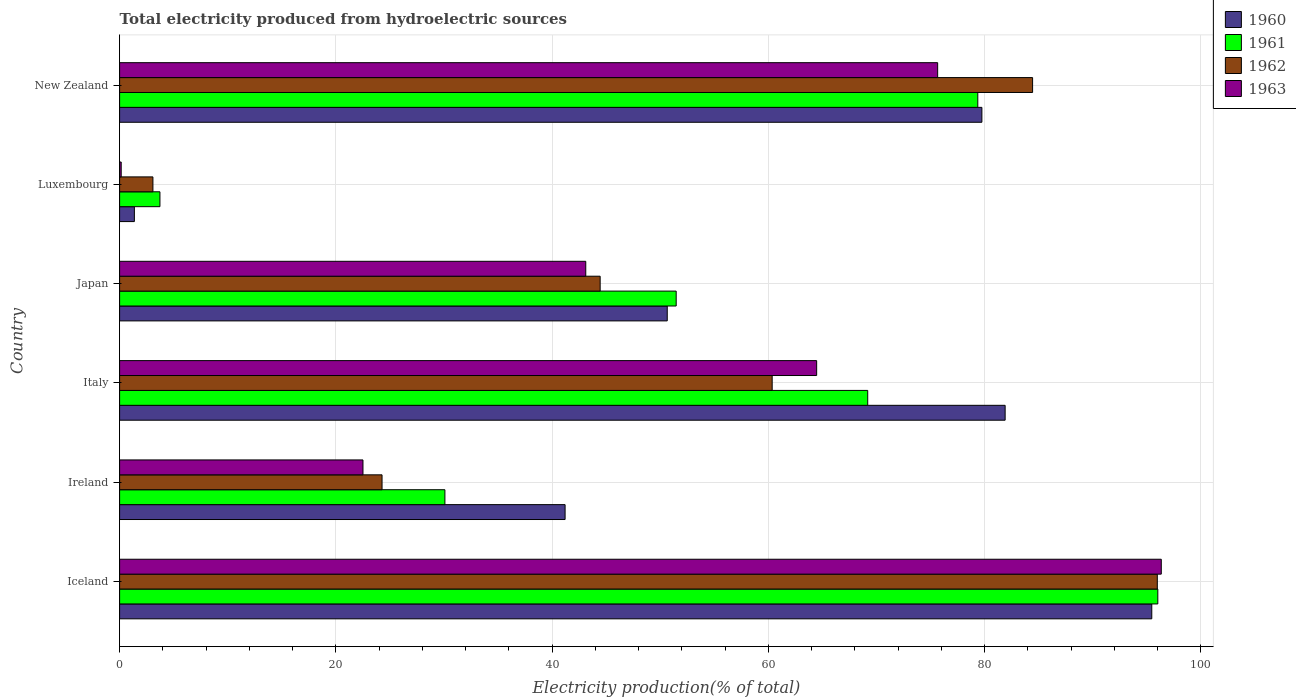How many groups of bars are there?
Keep it short and to the point. 6. Are the number of bars per tick equal to the number of legend labels?
Provide a succinct answer. Yes. How many bars are there on the 4th tick from the bottom?
Give a very brief answer. 4. What is the total electricity produced in 1963 in New Zealand?
Make the answer very short. 75.66. Across all countries, what is the maximum total electricity produced in 1962?
Provide a succinct answer. 95.97. Across all countries, what is the minimum total electricity produced in 1962?
Offer a very short reply. 3.08. In which country was the total electricity produced in 1962 minimum?
Provide a short and direct response. Luxembourg. What is the total total electricity produced in 1962 in the graph?
Offer a very short reply. 312.57. What is the difference between the total electricity produced in 1960 in Italy and that in New Zealand?
Make the answer very short. 2.15. What is the difference between the total electricity produced in 1962 in Iceland and the total electricity produced in 1961 in New Zealand?
Offer a very short reply. 16.6. What is the average total electricity produced in 1961 per country?
Your answer should be compact. 54.98. What is the difference between the total electricity produced in 1962 and total electricity produced in 1961 in Japan?
Provide a short and direct response. -7.03. In how many countries, is the total electricity produced in 1961 greater than 92 %?
Provide a short and direct response. 1. What is the ratio of the total electricity produced in 1963 in Ireland to that in Italy?
Your answer should be compact. 0.35. What is the difference between the highest and the second highest total electricity produced in 1963?
Provide a succinct answer. 20.68. What is the difference between the highest and the lowest total electricity produced in 1960?
Provide a short and direct response. 94.1. In how many countries, is the total electricity produced in 1962 greater than the average total electricity produced in 1962 taken over all countries?
Ensure brevity in your answer.  3. Is the sum of the total electricity produced in 1962 in Luxembourg and New Zealand greater than the maximum total electricity produced in 1963 across all countries?
Your answer should be compact. No. Is it the case that in every country, the sum of the total electricity produced in 1963 and total electricity produced in 1961 is greater than the sum of total electricity produced in 1962 and total electricity produced in 1960?
Ensure brevity in your answer.  No. What does the 4th bar from the bottom in Japan represents?
Provide a short and direct response. 1963. What is the difference between two consecutive major ticks on the X-axis?
Make the answer very short. 20. Does the graph contain grids?
Provide a succinct answer. Yes. How many legend labels are there?
Provide a succinct answer. 4. What is the title of the graph?
Make the answer very short. Total electricity produced from hydroelectric sources. What is the Electricity production(% of total) of 1960 in Iceland?
Offer a very short reply. 95.46. What is the Electricity production(% of total) in 1961 in Iceland?
Your response must be concise. 96.02. What is the Electricity production(% of total) in 1962 in Iceland?
Ensure brevity in your answer.  95.97. What is the Electricity production(% of total) in 1963 in Iceland?
Your response must be concise. 96.34. What is the Electricity production(% of total) in 1960 in Ireland?
Offer a very short reply. 41.2. What is the Electricity production(% of total) of 1961 in Ireland?
Keep it short and to the point. 30.09. What is the Electricity production(% of total) of 1962 in Ireland?
Your answer should be compact. 24.27. What is the Electricity production(% of total) of 1963 in Ireland?
Your answer should be very brief. 22.51. What is the Electricity production(% of total) in 1960 in Italy?
Your answer should be very brief. 81.9. What is the Electricity production(% of total) of 1961 in Italy?
Keep it short and to the point. 69.19. What is the Electricity production(% of total) of 1962 in Italy?
Provide a short and direct response. 60.35. What is the Electricity production(% of total) of 1963 in Italy?
Offer a terse response. 64.47. What is the Electricity production(% of total) of 1960 in Japan?
Make the answer very short. 50.65. What is the Electricity production(% of total) of 1961 in Japan?
Your answer should be compact. 51.48. What is the Electricity production(% of total) in 1962 in Japan?
Offer a terse response. 44.44. What is the Electricity production(% of total) in 1963 in Japan?
Ensure brevity in your answer.  43.11. What is the Electricity production(% of total) in 1960 in Luxembourg?
Ensure brevity in your answer.  1.37. What is the Electricity production(% of total) in 1961 in Luxembourg?
Make the answer very short. 3.73. What is the Electricity production(% of total) in 1962 in Luxembourg?
Provide a succinct answer. 3.08. What is the Electricity production(% of total) in 1963 in Luxembourg?
Keep it short and to the point. 0.15. What is the Electricity production(% of total) of 1960 in New Zealand?
Your response must be concise. 79.75. What is the Electricity production(% of total) of 1961 in New Zealand?
Your answer should be very brief. 79.37. What is the Electricity production(% of total) in 1962 in New Zealand?
Your response must be concise. 84.44. What is the Electricity production(% of total) in 1963 in New Zealand?
Provide a succinct answer. 75.66. Across all countries, what is the maximum Electricity production(% of total) in 1960?
Offer a very short reply. 95.46. Across all countries, what is the maximum Electricity production(% of total) of 1961?
Provide a short and direct response. 96.02. Across all countries, what is the maximum Electricity production(% of total) of 1962?
Give a very brief answer. 95.97. Across all countries, what is the maximum Electricity production(% of total) in 1963?
Offer a very short reply. 96.34. Across all countries, what is the minimum Electricity production(% of total) in 1960?
Offer a terse response. 1.37. Across all countries, what is the minimum Electricity production(% of total) in 1961?
Provide a succinct answer. 3.73. Across all countries, what is the minimum Electricity production(% of total) in 1962?
Offer a terse response. 3.08. Across all countries, what is the minimum Electricity production(% of total) of 1963?
Your response must be concise. 0.15. What is the total Electricity production(% of total) in 1960 in the graph?
Keep it short and to the point. 350.33. What is the total Electricity production(% of total) of 1961 in the graph?
Give a very brief answer. 329.87. What is the total Electricity production(% of total) of 1962 in the graph?
Offer a terse response. 312.57. What is the total Electricity production(% of total) of 1963 in the graph?
Provide a short and direct response. 302.24. What is the difference between the Electricity production(% of total) of 1960 in Iceland and that in Ireland?
Your answer should be very brief. 54.26. What is the difference between the Electricity production(% of total) in 1961 in Iceland and that in Ireland?
Keep it short and to the point. 65.93. What is the difference between the Electricity production(% of total) of 1962 in Iceland and that in Ireland?
Provide a short and direct response. 71.7. What is the difference between the Electricity production(% of total) of 1963 in Iceland and that in Ireland?
Ensure brevity in your answer.  73.83. What is the difference between the Electricity production(% of total) in 1960 in Iceland and that in Italy?
Provide a short and direct response. 13.56. What is the difference between the Electricity production(% of total) of 1961 in Iceland and that in Italy?
Ensure brevity in your answer.  26.83. What is the difference between the Electricity production(% of total) of 1962 in Iceland and that in Italy?
Your answer should be very brief. 35.62. What is the difference between the Electricity production(% of total) in 1963 in Iceland and that in Italy?
Offer a very short reply. 31.87. What is the difference between the Electricity production(% of total) of 1960 in Iceland and that in Japan?
Offer a very short reply. 44.81. What is the difference between the Electricity production(% of total) in 1961 in Iceland and that in Japan?
Your answer should be compact. 44.54. What is the difference between the Electricity production(% of total) of 1962 in Iceland and that in Japan?
Make the answer very short. 51.53. What is the difference between the Electricity production(% of total) in 1963 in Iceland and that in Japan?
Give a very brief answer. 53.23. What is the difference between the Electricity production(% of total) of 1960 in Iceland and that in Luxembourg?
Give a very brief answer. 94.1. What is the difference between the Electricity production(% of total) of 1961 in Iceland and that in Luxembourg?
Your response must be concise. 92.29. What is the difference between the Electricity production(% of total) in 1962 in Iceland and that in Luxembourg?
Give a very brief answer. 92.89. What is the difference between the Electricity production(% of total) of 1963 in Iceland and that in Luxembourg?
Keep it short and to the point. 96.19. What is the difference between the Electricity production(% of total) of 1960 in Iceland and that in New Zealand?
Give a very brief answer. 15.71. What is the difference between the Electricity production(% of total) of 1961 in Iceland and that in New Zealand?
Offer a very short reply. 16.65. What is the difference between the Electricity production(% of total) in 1962 in Iceland and that in New Zealand?
Offer a terse response. 11.54. What is the difference between the Electricity production(% of total) in 1963 in Iceland and that in New Zealand?
Your answer should be very brief. 20.68. What is the difference between the Electricity production(% of total) in 1960 in Ireland and that in Italy?
Offer a very short reply. -40.7. What is the difference between the Electricity production(% of total) in 1961 in Ireland and that in Italy?
Your answer should be very brief. -39.1. What is the difference between the Electricity production(% of total) in 1962 in Ireland and that in Italy?
Your answer should be very brief. -36.08. What is the difference between the Electricity production(% of total) of 1963 in Ireland and that in Italy?
Your response must be concise. -41.96. What is the difference between the Electricity production(% of total) in 1960 in Ireland and that in Japan?
Keep it short and to the point. -9.45. What is the difference between the Electricity production(% of total) of 1961 in Ireland and that in Japan?
Offer a very short reply. -21.39. What is the difference between the Electricity production(% of total) of 1962 in Ireland and that in Japan?
Keep it short and to the point. -20.17. What is the difference between the Electricity production(% of total) of 1963 in Ireland and that in Japan?
Your response must be concise. -20.61. What is the difference between the Electricity production(% of total) in 1960 in Ireland and that in Luxembourg?
Your answer should be compact. 39.84. What is the difference between the Electricity production(% of total) in 1961 in Ireland and that in Luxembourg?
Your answer should be very brief. 26.36. What is the difference between the Electricity production(% of total) of 1962 in Ireland and that in Luxembourg?
Provide a succinct answer. 21.19. What is the difference between the Electricity production(% of total) in 1963 in Ireland and that in Luxembourg?
Your answer should be compact. 22.36. What is the difference between the Electricity production(% of total) in 1960 in Ireland and that in New Zealand?
Your response must be concise. -38.55. What is the difference between the Electricity production(% of total) of 1961 in Ireland and that in New Zealand?
Your answer should be compact. -49.29. What is the difference between the Electricity production(% of total) in 1962 in Ireland and that in New Zealand?
Your answer should be compact. -60.17. What is the difference between the Electricity production(% of total) of 1963 in Ireland and that in New Zealand?
Your response must be concise. -53.15. What is the difference between the Electricity production(% of total) of 1960 in Italy and that in Japan?
Offer a very short reply. 31.25. What is the difference between the Electricity production(% of total) of 1961 in Italy and that in Japan?
Provide a short and direct response. 17.71. What is the difference between the Electricity production(% of total) in 1962 in Italy and that in Japan?
Ensure brevity in your answer.  15.91. What is the difference between the Electricity production(% of total) of 1963 in Italy and that in Japan?
Your answer should be very brief. 21.35. What is the difference between the Electricity production(% of total) in 1960 in Italy and that in Luxembourg?
Your answer should be compact. 80.53. What is the difference between the Electricity production(% of total) in 1961 in Italy and that in Luxembourg?
Provide a succinct answer. 65.46. What is the difference between the Electricity production(% of total) in 1962 in Italy and that in Luxembourg?
Your response must be concise. 57.27. What is the difference between the Electricity production(% of total) in 1963 in Italy and that in Luxembourg?
Offer a terse response. 64.32. What is the difference between the Electricity production(% of total) of 1960 in Italy and that in New Zealand?
Give a very brief answer. 2.15. What is the difference between the Electricity production(% of total) in 1961 in Italy and that in New Zealand?
Offer a very short reply. -10.18. What is the difference between the Electricity production(% of total) in 1962 in Italy and that in New Zealand?
Your answer should be very brief. -24.08. What is the difference between the Electricity production(% of total) of 1963 in Italy and that in New Zealand?
Your answer should be compact. -11.19. What is the difference between the Electricity production(% of total) of 1960 in Japan and that in Luxembourg?
Your response must be concise. 49.28. What is the difference between the Electricity production(% of total) in 1961 in Japan and that in Luxembourg?
Provide a succinct answer. 47.75. What is the difference between the Electricity production(% of total) in 1962 in Japan and that in Luxembourg?
Your response must be concise. 41.36. What is the difference between the Electricity production(% of total) in 1963 in Japan and that in Luxembourg?
Your answer should be compact. 42.97. What is the difference between the Electricity production(% of total) in 1960 in Japan and that in New Zealand?
Make the answer very short. -29.1. What is the difference between the Electricity production(% of total) in 1961 in Japan and that in New Zealand?
Make the answer very short. -27.9. What is the difference between the Electricity production(% of total) of 1962 in Japan and that in New Zealand?
Offer a very short reply. -39.99. What is the difference between the Electricity production(% of total) of 1963 in Japan and that in New Zealand?
Your answer should be compact. -32.54. What is the difference between the Electricity production(% of total) of 1960 in Luxembourg and that in New Zealand?
Make the answer very short. -78.38. What is the difference between the Electricity production(% of total) in 1961 in Luxembourg and that in New Zealand?
Your answer should be compact. -75.64. What is the difference between the Electricity production(% of total) in 1962 in Luxembourg and that in New Zealand?
Your answer should be very brief. -81.36. What is the difference between the Electricity production(% of total) in 1963 in Luxembourg and that in New Zealand?
Make the answer very short. -75.51. What is the difference between the Electricity production(% of total) in 1960 in Iceland and the Electricity production(% of total) in 1961 in Ireland?
Ensure brevity in your answer.  65.38. What is the difference between the Electricity production(% of total) of 1960 in Iceland and the Electricity production(% of total) of 1962 in Ireland?
Provide a short and direct response. 71.19. What is the difference between the Electricity production(% of total) of 1960 in Iceland and the Electricity production(% of total) of 1963 in Ireland?
Your answer should be very brief. 72.95. What is the difference between the Electricity production(% of total) of 1961 in Iceland and the Electricity production(% of total) of 1962 in Ireland?
Provide a short and direct response. 71.75. What is the difference between the Electricity production(% of total) in 1961 in Iceland and the Electricity production(% of total) in 1963 in Ireland?
Ensure brevity in your answer.  73.51. What is the difference between the Electricity production(% of total) in 1962 in Iceland and the Electricity production(% of total) in 1963 in Ireland?
Ensure brevity in your answer.  73.47. What is the difference between the Electricity production(% of total) in 1960 in Iceland and the Electricity production(% of total) in 1961 in Italy?
Offer a very short reply. 26.27. What is the difference between the Electricity production(% of total) in 1960 in Iceland and the Electricity production(% of total) in 1962 in Italy?
Keep it short and to the point. 35.11. What is the difference between the Electricity production(% of total) of 1960 in Iceland and the Electricity production(% of total) of 1963 in Italy?
Provide a short and direct response. 30.99. What is the difference between the Electricity production(% of total) in 1961 in Iceland and the Electricity production(% of total) in 1962 in Italy?
Your response must be concise. 35.67. What is the difference between the Electricity production(% of total) in 1961 in Iceland and the Electricity production(% of total) in 1963 in Italy?
Ensure brevity in your answer.  31.55. What is the difference between the Electricity production(% of total) of 1962 in Iceland and the Electricity production(% of total) of 1963 in Italy?
Offer a very short reply. 31.51. What is the difference between the Electricity production(% of total) of 1960 in Iceland and the Electricity production(% of total) of 1961 in Japan?
Keep it short and to the point. 43.99. What is the difference between the Electricity production(% of total) of 1960 in Iceland and the Electricity production(% of total) of 1962 in Japan?
Provide a short and direct response. 51.02. What is the difference between the Electricity production(% of total) in 1960 in Iceland and the Electricity production(% of total) in 1963 in Japan?
Make the answer very short. 52.35. What is the difference between the Electricity production(% of total) of 1961 in Iceland and the Electricity production(% of total) of 1962 in Japan?
Give a very brief answer. 51.58. What is the difference between the Electricity production(% of total) in 1961 in Iceland and the Electricity production(% of total) in 1963 in Japan?
Provide a short and direct response. 52.91. What is the difference between the Electricity production(% of total) in 1962 in Iceland and the Electricity production(% of total) in 1963 in Japan?
Provide a succinct answer. 52.86. What is the difference between the Electricity production(% of total) of 1960 in Iceland and the Electricity production(% of total) of 1961 in Luxembourg?
Offer a terse response. 91.73. What is the difference between the Electricity production(% of total) in 1960 in Iceland and the Electricity production(% of total) in 1962 in Luxembourg?
Your answer should be compact. 92.38. What is the difference between the Electricity production(% of total) in 1960 in Iceland and the Electricity production(% of total) in 1963 in Luxembourg?
Your answer should be compact. 95.32. What is the difference between the Electricity production(% of total) in 1961 in Iceland and the Electricity production(% of total) in 1962 in Luxembourg?
Offer a terse response. 92.94. What is the difference between the Electricity production(% of total) in 1961 in Iceland and the Electricity production(% of total) in 1963 in Luxembourg?
Provide a succinct answer. 95.87. What is the difference between the Electricity production(% of total) of 1962 in Iceland and the Electricity production(% of total) of 1963 in Luxembourg?
Make the answer very short. 95.83. What is the difference between the Electricity production(% of total) of 1960 in Iceland and the Electricity production(% of total) of 1961 in New Zealand?
Provide a short and direct response. 16.09. What is the difference between the Electricity production(% of total) in 1960 in Iceland and the Electricity production(% of total) in 1962 in New Zealand?
Your answer should be compact. 11.02. What is the difference between the Electricity production(% of total) of 1960 in Iceland and the Electricity production(% of total) of 1963 in New Zealand?
Your answer should be very brief. 19.8. What is the difference between the Electricity production(% of total) of 1961 in Iceland and the Electricity production(% of total) of 1962 in New Zealand?
Keep it short and to the point. 11.58. What is the difference between the Electricity production(% of total) of 1961 in Iceland and the Electricity production(% of total) of 1963 in New Zealand?
Offer a terse response. 20.36. What is the difference between the Electricity production(% of total) of 1962 in Iceland and the Electricity production(% of total) of 1963 in New Zealand?
Make the answer very short. 20.32. What is the difference between the Electricity production(% of total) in 1960 in Ireland and the Electricity production(% of total) in 1961 in Italy?
Your answer should be compact. -27.99. What is the difference between the Electricity production(% of total) in 1960 in Ireland and the Electricity production(% of total) in 1962 in Italy?
Offer a very short reply. -19.15. What is the difference between the Electricity production(% of total) in 1960 in Ireland and the Electricity production(% of total) in 1963 in Italy?
Give a very brief answer. -23.27. What is the difference between the Electricity production(% of total) in 1961 in Ireland and the Electricity production(% of total) in 1962 in Italy?
Keep it short and to the point. -30.27. What is the difference between the Electricity production(% of total) of 1961 in Ireland and the Electricity production(% of total) of 1963 in Italy?
Ensure brevity in your answer.  -34.38. What is the difference between the Electricity production(% of total) in 1962 in Ireland and the Electricity production(% of total) in 1963 in Italy?
Your answer should be compact. -40.2. What is the difference between the Electricity production(% of total) of 1960 in Ireland and the Electricity production(% of total) of 1961 in Japan?
Ensure brevity in your answer.  -10.27. What is the difference between the Electricity production(% of total) in 1960 in Ireland and the Electricity production(% of total) in 1962 in Japan?
Provide a succinct answer. -3.24. What is the difference between the Electricity production(% of total) of 1960 in Ireland and the Electricity production(% of total) of 1963 in Japan?
Keep it short and to the point. -1.91. What is the difference between the Electricity production(% of total) of 1961 in Ireland and the Electricity production(% of total) of 1962 in Japan?
Your response must be concise. -14.36. What is the difference between the Electricity production(% of total) of 1961 in Ireland and the Electricity production(% of total) of 1963 in Japan?
Offer a terse response. -13.03. What is the difference between the Electricity production(% of total) in 1962 in Ireland and the Electricity production(% of total) in 1963 in Japan?
Make the answer very short. -18.84. What is the difference between the Electricity production(% of total) in 1960 in Ireland and the Electricity production(% of total) in 1961 in Luxembourg?
Your response must be concise. 37.47. What is the difference between the Electricity production(% of total) of 1960 in Ireland and the Electricity production(% of total) of 1962 in Luxembourg?
Your response must be concise. 38.12. What is the difference between the Electricity production(% of total) of 1960 in Ireland and the Electricity production(% of total) of 1963 in Luxembourg?
Give a very brief answer. 41.05. What is the difference between the Electricity production(% of total) of 1961 in Ireland and the Electricity production(% of total) of 1962 in Luxembourg?
Your answer should be very brief. 27. What is the difference between the Electricity production(% of total) in 1961 in Ireland and the Electricity production(% of total) in 1963 in Luxembourg?
Keep it short and to the point. 29.94. What is the difference between the Electricity production(% of total) in 1962 in Ireland and the Electricity production(% of total) in 1963 in Luxembourg?
Offer a very short reply. 24.12. What is the difference between the Electricity production(% of total) in 1960 in Ireland and the Electricity production(% of total) in 1961 in New Zealand?
Your response must be concise. -38.17. What is the difference between the Electricity production(% of total) of 1960 in Ireland and the Electricity production(% of total) of 1962 in New Zealand?
Provide a succinct answer. -43.24. What is the difference between the Electricity production(% of total) in 1960 in Ireland and the Electricity production(% of total) in 1963 in New Zealand?
Ensure brevity in your answer.  -34.46. What is the difference between the Electricity production(% of total) of 1961 in Ireland and the Electricity production(% of total) of 1962 in New Zealand?
Provide a succinct answer. -54.35. What is the difference between the Electricity production(% of total) in 1961 in Ireland and the Electricity production(% of total) in 1963 in New Zealand?
Your answer should be compact. -45.57. What is the difference between the Electricity production(% of total) in 1962 in Ireland and the Electricity production(% of total) in 1963 in New Zealand?
Offer a very short reply. -51.39. What is the difference between the Electricity production(% of total) in 1960 in Italy and the Electricity production(% of total) in 1961 in Japan?
Offer a very short reply. 30.42. What is the difference between the Electricity production(% of total) of 1960 in Italy and the Electricity production(% of total) of 1962 in Japan?
Keep it short and to the point. 37.46. What is the difference between the Electricity production(% of total) of 1960 in Italy and the Electricity production(% of total) of 1963 in Japan?
Your response must be concise. 38.79. What is the difference between the Electricity production(% of total) in 1961 in Italy and the Electricity production(% of total) in 1962 in Japan?
Make the answer very short. 24.75. What is the difference between the Electricity production(% of total) in 1961 in Italy and the Electricity production(% of total) in 1963 in Japan?
Offer a terse response. 26.08. What is the difference between the Electricity production(% of total) of 1962 in Italy and the Electricity production(% of total) of 1963 in Japan?
Your answer should be compact. 17.24. What is the difference between the Electricity production(% of total) of 1960 in Italy and the Electricity production(% of total) of 1961 in Luxembourg?
Make the answer very short. 78.17. What is the difference between the Electricity production(% of total) of 1960 in Italy and the Electricity production(% of total) of 1962 in Luxembourg?
Your response must be concise. 78.82. What is the difference between the Electricity production(% of total) of 1960 in Italy and the Electricity production(% of total) of 1963 in Luxembourg?
Give a very brief answer. 81.75. What is the difference between the Electricity production(% of total) of 1961 in Italy and the Electricity production(% of total) of 1962 in Luxembourg?
Provide a short and direct response. 66.11. What is the difference between the Electricity production(% of total) of 1961 in Italy and the Electricity production(% of total) of 1963 in Luxembourg?
Your answer should be compact. 69.04. What is the difference between the Electricity production(% of total) in 1962 in Italy and the Electricity production(% of total) in 1963 in Luxembourg?
Make the answer very short. 60.21. What is the difference between the Electricity production(% of total) of 1960 in Italy and the Electricity production(% of total) of 1961 in New Zealand?
Make the answer very short. 2.53. What is the difference between the Electricity production(% of total) in 1960 in Italy and the Electricity production(% of total) in 1962 in New Zealand?
Your response must be concise. -2.54. What is the difference between the Electricity production(% of total) in 1960 in Italy and the Electricity production(% of total) in 1963 in New Zealand?
Your answer should be compact. 6.24. What is the difference between the Electricity production(% of total) of 1961 in Italy and the Electricity production(% of total) of 1962 in New Zealand?
Your response must be concise. -15.25. What is the difference between the Electricity production(% of total) of 1961 in Italy and the Electricity production(% of total) of 1963 in New Zealand?
Provide a succinct answer. -6.47. What is the difference between the Electricity production(% of total) in 1962 in Italy and the Electricity production(% of total) in 1963 in New Zealand?
Give a very brief answer. -15.3. What is the difference between the Electricity production(% of total) of 1960 in Japan and the Electricity production(% of total) of 1961 in Luxembourg?
Offer a very short reply. 46.92. What is the difference between the Electricity production(% of total) of 1960 in Japan and the Electricity production(% of total) of 1962 in Luxembourg?
Offer a very short reply. 47.57. What is the difference between the Electricity production(% of total) of 1960 in Japan and the Electricity production(% of total) of 1963 in Luxembourg?
Make the answer very short. 50.5. What is the difference between the Electricity production(% of total) in 1961 in Japan and the Electricity production(% of total) in 1962 in Luxembourg?
Provide a succinct answer. 48.39. What is the difference between the Electricity production(% of total) in 1961 in Japan and the Electricity production(% of total) in 1963 in Luxembourg?
Ensure brevity in your answer.  51.33. What is the difference between the Electricity production(% of total) in 1962 in Japan and the Electricity production(% of total) in 1963 in Luxembourg?
Your response must be concise. 44.3. What is the difference between the Electricity production(% of total) of 1960 in Japan and the Electricity production(% of total) of 1961 in New Zealand?
Make the answer very short. -28.72. What is the difference between the Electricity production(% of total) of 1960 in Japan and the Electricity production(% of total) of 1962 in New Zealand?
Keep it short and to the point. -33.79. What is the difference between the Electricity production(% of total) in 1960 in Japan and the Electricity production(% of total) in 1963 in New Zealand?
Provide a succinct answer. -25.01. What is the difference between the Electricity production(% of total) of 1961 in Japan and the Electricity production(% of total) of 1962 in New Zealand?
Ensure brevity in your answer.  -32.96. What is the difference between the Electricity production(% of total) of 1961 in Japan and the Electricity production(% of total) of 1963 in New Zealand?
Your answer should be compact. -24.18. What is the difference between the Electricity production(% of total) of 1962 in Japan and the Electricity production(% of total) of 1963 in New Zealand?
Your response must be concise. -31.21. What is the difference between the Electricity production(% of total) of 1960 in Luxembourg and the Electricity production(% of total) of 1961 in New Zealand?
Offer a terse response. -78.01. What is the difference between the Electricity production(% of total) in 1960 in Luxembourg and the Electricity production(% of total) in 1962 in New Zealand?
Your answer should be compact. -83.07. What is the difference between the Electricity production(% of total) of 1960 in Luxembourg and the Electricity production(% of total) of 1963 in New Zealand?
Offer a very short reply. -74.29. What is the difference between the Electricity production(% of total) in 1961 in Luxembourg and the Electricity production(% of total) in 1962 in New Zealand?
Provide a succinct answer. -80.71. What is the difference between the Electricity production(% of total) of 1961 in Luxembourg and the Electricity production(% of total) of 1963 in New Zealand?
Keep it short and to the point. -71.93. What is the difference between the Electricity production(% of total) of 1962 in Luxembourg and the Electricity production(% of total) of 1963 in New Zealand?
Ensure brevity in your answer.  -72.58. What is the average Electricity production(% of total) in 1960 per country?
Offer a very short reply. 58.39. What is the average Electricity production(% of total) in 1961 per country?
Offer a terse response. 54.98. What is the average Electricity production(% of total) in 1962 per country?
Your answer should be compact. 52.09. What is the average Electricity production(% of total) in 1963 per country?
Provide a short and direct response. 50.37. What is the difference between the Electricity production(% of total) in 1960 and Electricity production(% of total) in 1961 in Iceland?
Your answer should be very brief. -0.56. What is the difference between the Electricity production(% of total) in 1960 and Electricity production(% of total) in 1962 in Iceland?
Offer a very short reply. -0.51. What is the difference between the Electricity production(% of total) in 1960 and Electricity production(% of total) in 1963 in Iceland?
Offer a very short reply. -0.88. What is the difference between the Electricity production(% of total) in 1961 and Electricity production(% of total) in 1962 in Iceland?
Give a very brief answer. 0.05. What is the difference between the Electricity production(% of total) of 1961 and Electricity production(% of total) of 1963 in Iceland?
Provide a short and direct response. -0.32. What is the difference between the Electricity production(% of total) in 1962 and Electricity production(% of total) in 1963 in Iceland?
Make the answer very short. -0.37. What is the difference between the Electricity production(% of total) of 1960 and Electricity production(% of total) of 1961 in Ireland?
Provide a short and direct response. 11.12. What is the difference between the Electricity production(% of total) of 1960 and Electricity production(% of total) of 1962 in Ireland?
Offer a terse response. 16.93. What is the difference between the Electricity production(% of total) in 1960 and Electricity production(% of total) in 1963 in Ireland?
Make the answer very short. 18.69. What is the difference between the Electricity production(% of total) of 1961 and Electricity production(% of total) of 1962 in Ireland?
Provide a succinct answer. 5.81. What is the difference between the Electricity production(% of total) of 1961 and Electricity production(% of total) of 1963 in Ireland?
Give a very brief answer. 7.58. What is the difference between the Electricity production(% of total) in 1962 and Electricity production(% of total) in 1963 in Ireland?
Give a very brief answer. 1.76. What is the difference between the Electricity production(% of total) of 1960 and Electricity production(% of total) of 1961 in Italy?
Your response must be concise. 12.71. What is the difference between the Electricity production(% of total) in 1960 and Electricity production(% of total) in 1962 in Italy?
Provide a short and direct response. 21.55. What is the difference between the Electricity production(% of total) of 1960 and Electricity production(% of total) of 1963 in Italy?
Your answer should be compact. 17.43. What is the difference between the Electricity production(% of total) in 1961 and Electricity production(% of total) in 1962 in Italy?
Provide a short and direct response. 8.84. What is the difference between the Electricity production(% of total) in 1961 and Electricity production(% of total) in 1963 in Italy?
Your answer should be very brief. 4.72. What is the difference between the Electricity production(% of total) of 1962 and Electricity production(% of total) of 1963 in Italy?
Offer a very short reply. -4.11. What is the difference between the Electricity production(% of total) in 1960 and Electricity production(% of total) in 1961 in Japan?
Your answer should be compact. -0.83. What is the difference between the Electricity production(% of total) of 1960 and Electricity production(% of total) of 1962 in Japan?
Provide a short and direct response. 6.2. What is the difference between the Electricity production(% of total) of 1960 and Electricity production(% of total) of 1963 in Japan?
Offer a very short reply. 7.54. What is the difference between the Electricity production(% of total) in 1961 and Electricity production(% of total) in 1962 in Japan?
Your response must be concise. 7.03. What is the difference between the Electricity production(% of total) in 1961 and Electricity production(% of total) in 1963 in Japan?
Make the answer very short. 8.36. What is the difference between the Electricity production(% of total) of 1962 and Electricity production(% of total) of 1963 in Japan?
Make the answer very short. 1.33. What is the difference between the Electricity production(% of total) of 1960 and Electricity production(% of total) of 1961 in Luxembourg?
Your response must be concise. -2.36. What is the difference between the Electricity production(% of total) in 1960 and Electricity production(% of total) in 1962 in Luxembourg?
Provide a short and direct response. -1.72. What is the difference between the Electricity production(% of total) of 1960 and Electricity production(% of total) of 1963 in Luxembourg?
Ensure brevity in your answer.  1.22. What is the difference between the Electricity production(% of total) of 1961 and Electricity production(% of total) of 1962 in Luxembourg?
Provide a succinct answer. 0.65. What is the difference between the Electricity production(% of total) in 1961 and Electricity production(% of total) in 1963 in Luxembourg?
Provide a succinct answer. 3.58. What is the difference between the Electricity production(% of total) of 1962 and Electricity production(% of total) of 1963 in Luxembourg?
Your response must be concise. 2.93. What is the difference between the Electricity production(% of total) of 1960 and Electricity production(% of total) of 1961 in New Zealand?
Ensure brevity in your answer.  0.38. What is the difference between the Electricity production(% of total) in 1960 and Electricity production(% of total) in 1962 in New Zealand?
Offer a very short reply. -4.69. What is the difference between the Electricity production(% of total) of 1960 and Electricity production(% of total) of 1963 in New Zealand?
Give a very brief answer. 4.09. What is the difference between the Electricity production(% of total) in 1961 and Electricity production(% of total) in 1962 in New Zealand?
Offer a very short reply. -5.07. What is the difference between the Electricity production(% of total) in 1961 and Electricity production(% of total) in 1963 in New Zealand?
Your answer should be very brief. 3.71. What is the difference between the Electricity production(% of total) of 1962 and Electricity production(% of total) of 1963 in New Zealand?
Give a very brief answer. 8.78. What is the ratio of the Electricity production(% of total) in 1960 in Iceland to that in Ireland?
Offer a very short reply. 2.32. What is the ratio of the Electricity production(% of total) in 1961 in Iceland to that in Ireland?
Offer a very short reply. 3.19. What is the ratio of the Electricity production(% of total) of 1962 in Iceland to that in Ireland?
Provide a short and direct response. 3.95. What is the ratio of the Electricity production(% of total) of 1963 in Iceland to that in Ireland?
Your answer should be very brief. 4.28. What is the ratio of the Electricity production(% of total) in 1960 in Iceland to that in Italy?
Your answer should be compact. 1.17. What is the ratio of the Electricity production(% of total) of 1961 in Iceland to that in Italy?
Offer a very short reply. 1.39. What is the ratio of the Electricity production(% of total) of 1962 in Iceland to that in Italy?
Your answer should be very brief. 1.59. What is the ratio of the Electricity production(% of total) in 1963 in Iceland to that in Italy?
Your response must be concise. 1.49. What is the ratio of the Electricity production(% of total) of 1960 in Iceland to that in Japan?
Offer a very short reply. 1.88. What is the ratio of the Electricity production(% of total) in 1961 in Iceland to that in Japan?
Give a very brief answer. 1.87. What is the ratio of the Electricity production(% of total) of 1962 in Iceland to that in Japan?
Give a very brief answer. 2.16. What is the ratio of the Electricity production(% of total) in 1963 in Iceland to that in Japan?
Your answer should be very brief. 2.23. What is the ratio of the Electricity production(% of total) of 1960 in Iceland to that in Luxembourg?
Provide a succinct answer. 69.88. What is the ratio of the Electricity production(% of total) in 1961 in Iceland to that in Luxembourg?
Your answer should be compact. 25.74. What is the ratio of the Electricity production(% of total) in 1962 in Iceland to that in Luxembourg?
Provide a short and direct response. 31.14. What is the ratio of the Electricity production(% of total) of 1963 in Iceland to that in Luxembourg?
Your response must be concise. 652.71. What is the ratio of the Electricity production(% of total) of 1960 in Iceland to that in New Zealand?
Make the answer very short. 1.2. What is the ratio of the Electricity production(% of total) of 1961 in Iceland to that in New Zealand?
Your response must be concise. 1.21. What is the ratio of the Electricity production(% of total) of 1962 in Iceland to that in New Zealand?
Keep it short and to the point. 1.14. What is the ratio of the Electricity production(% of total) in 1963 in Iceland to that in New Zealand?
Provide a short and direct response. 1.27. What is the ratio of the Electricity production(% of total) in 1960 in Ireland to that in Italy?
Provide a succinct answer. 0.5. What is the ratio of the Electricity production(% of total) in 1961 in Ireland to that in Italy?
Offer a terse response. 0.43. What is the ratio of the Electricity production(% of total) of 1962 in Ireland to that in Italy?
Ensure brevity in your answer.  0.4. What is the ratio of the Electricity production(% of total) in 1963 in Ireland to that in Italy?
Ensure brevity in your answer.  0.35. What is the ratio of the Electricity production(% of total) in 1960 in Ireland to that in Japan?
Provide a succinct answer. 0.81. What is the ratio of the Electricity production(% of total) in 1961 in Ireland to that in Japan?
Make the answer very short. 0.58. What is the ratio of the Electricity production(% of total) of 1962 in Ireland to that in Japan?
Your response must be concise. 0.55. What is the ratio of the Electricity production(% of total) in 1963 in Ireland to that in Japan?
Offer a terse response. 0.52. What is the ratio of the Electricity production(% of total) of 1960 in Ireland to that in Luxembourg?
Provide a succinct answer. 30.16. What is the ratio of the Electricity production(% of total) in 1961 in Ireland to that in Luxembourg?
Offer a terse response. 8.07. What is the ratio of the Electricity production(% of total) in 1962 in Ireland to that in Luxembourg?
Provide a succinct answer. 7.88. What is the ratio of the Electricity production(% of total) of 1963 in Ireland to that in Luxembourg?
Make the answer very short. 152.5. What is the ratio of the Electricity production(% of total) of 1960 in Ireland to that in New Zealand?
Provide a succinct answer. 0.52. What is the ratio of the Electricity production(% of total) of 1961 in Ireland to that in New Zealand?
Provide a short and direct response. 0.38. What is the ratio of the Electricity production(% of total) of 1962 in Ireland to that in New Zealand?
Your response must be concise. 0.29. What is the ratio of the Electricity production(% of total) of 1963 in Ireland to that in New Zealand?
Give a very brief answer. 0.3. What is the ratio of the Electricity production(% of total) of 1960 in Italy to that in Japan?
Offer a very short reply. 1.62. What is the ratio of the Electricity production(% of total) of 1961 in Italy to that in Japan?
Your answer should be very brief. 1.34. What is the ratio of the Electricity production(% of total) in 1962 in Italy to that in Japan?
Your response must be concise. 1.36. What is the ratio of the Electricity production(% of total) in 1963 in Italy to that in Japan?
Ensure brevity in your answer.  1.5. What is the ratio of the Electricity production(% of total) in 1960 in Italy to that in Luxembourg?
Ensure brevity in your answer.  59.95. What is the ratio of the Electricity production(% of total) in 1961 in Italy to that in Luxembourg?
Keep it short and to the point. 18.55. What is the ratio of the Electricity production(% of total) of 1962 in Italy to that in Luxembourg?
Make the answer very short. 19.58. What is the ratio of the Electricity production(% of total) of 1963 in Italy to that in Luxembourg?
Keep it short and to the point. 436.77. What is the ratio of the Electricity production(% of total) in 1961 in Italy to that in New Zealand?
Provide a succinct answer. 0.87. What is the ratio of the Electricity production(% of total) in 1962 in Italy to that in New Zealand?
Ensure brevity in your answer.  0.71. What is the ratio of the Electricity production(% of total) of 1963 in Italy to that in New Zealand?
Offer a terse response. 0.85. What is the ratio of the Electricity production(% of total) in 1960 in Japan to that in Luxembourg?
Keep it short and to the point. 37.08. What is the ratio of the Electricity production(% of total) in 1961 in Japan to that in Luxembourg?
Offer a very short reply. 13.8. What is the ratio of the Electricity production(% of total) in 1962 in Japan to that in Luxembourg?
Provide a succinct answer. 14.42. What is the ratio of the Electricity production(% of total) in 1963 in Japan to that in Luxembourg?
Make the answer very short. 292.1. What is the ratio of the Electricity production(% of total) in 1960 in Japan to that in New Zealand?
Provide a short and direct response. 0.64. What is the ratio of the Electricity production(% of total) of 1961 in Japan to that in New Zealand?
Make the answer very short. 0.65. What is the ratio of the Electricity production(% of total) of 1962 in Japan to that in New Zealand?
Offer a very short reply. 0.53. What is the ratio of the Electricity production(% of total) in 1963 in Japan to that in New Zealand?
Ensure brevity in your answer.  0.57. What is the ratio of the Electricity production(% of total) of 1960 in Luxembourg to that in New Zealand?
Make the answer very short. 0.02. What is the ratio of the Electricity production(% of total) of 1961 in Luxembourg to that in New Zealand?
Make the answer very short. 0.05. What is the ratio of the Electricity production(% of total) of 1962 in Luxembourg to that in New Zealand?
Keep it short and to the point. 0.04. What is the ratio of the Electricity production(% of total) of 1963 in Luxembourg to that in New Zealand?
Your answer should be compact. 0. What is the difference between the highest and the second highest Electricity production(% of total) in 1960?
Give a very brief answer. 13.56. What is the difference between the highest and the second highest Electricity production(% of total) of 1961?
Make the answer very short. 16.65. What is the difference between the highest and the second highest Electricity production(% of total) of 1962?
Ensure brevity in your answer.  11.54. What is the difference between the highest and the second highest Electricity production(% of total) of 1963?
Provide a short and direct response. 20.68. What is the difference between the highest and the lowest Electricity production(% of total) of 1960?
Your answer should be very brief. 94.1. What is the difference between the highest and the lowest Electricity production(% of total) in 1961?
Make the answer very short. 92.29. What is the difference between the highest and the lowest Electricity production(% of total) of 1962?
Provide a short and direct response. 92.89. What is the difference between the highest and the lowest Electricity production(% of total) in 1963?
Your answer should be compact. 96.19. 